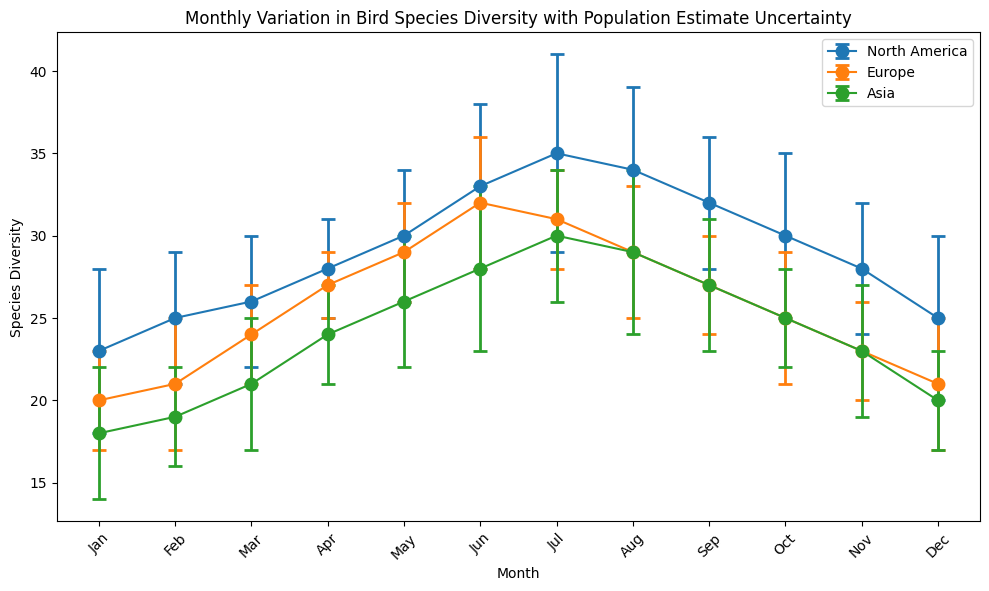Which region has the highest species diversity in June? The North America data point in June is the highest among all regions. It has a species diversity of 33.
Answer: North America Which month has the lowest species diversity for Asia? Asia has its lowest species diversity in January and December, both with a value of 18 and 20 respectively. Comparing these months against all others confirms January is the lowest.
Answer: January In which month does Europe have higher species diversity than Asia? Comparing the values, Europe has a higher species diversity than Asia in all months except June and July. For example, in May, Europe has 29 while Asia has 26.
Answer: All months except June and July Which region shows the largest uncertainty in population estimates in July? For July, checking the error bars, North America has the largest uncertainty value with an uncertainty of 6.
Answer: North America What's the difference in species diversity between North America and Europe in April? In North America, April has a diversity of 28, and Europe has 27. The difference is 28 - 27.
Answer: 1 In which month does North America have the maximum species diversity? North America reaches its peak species diversity in July with a value of 35.
Answer: July If you average the species diversity of Europe across the first quarter of the year (Jan, Feb, Mar), what value do you get? The average calculation involves adding the values for Jan (20), Feb (21), and Mar (24), then dividing by 3: (20 + 21 + 24) / 3 = 21.67.
Answer: 21.67 How does the species diversity trend across the months for Asia generally look? The trend starts lower, increases until July, peaks, and then decreases towards December.
Answer: Increasing till July, then decreasing Which region shows the smallest variation in species diversity from January to December? Europe has the smallest range, varying from 20 to 32, with smaller monthly changes compared to North America and Asia.
Answer: Europe 